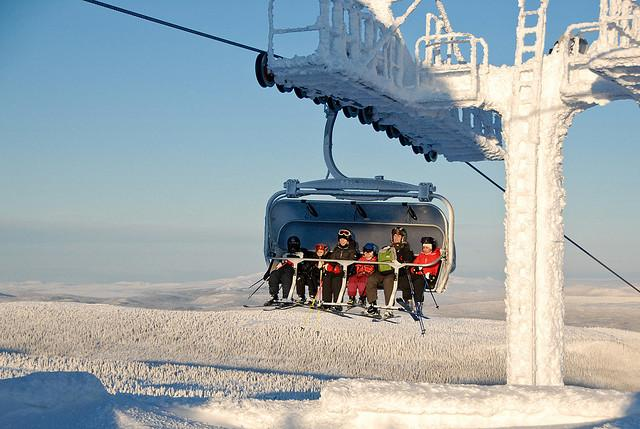Where is this group headed?

Choices:
A) disney world
B) down
C) no where
D) up up 